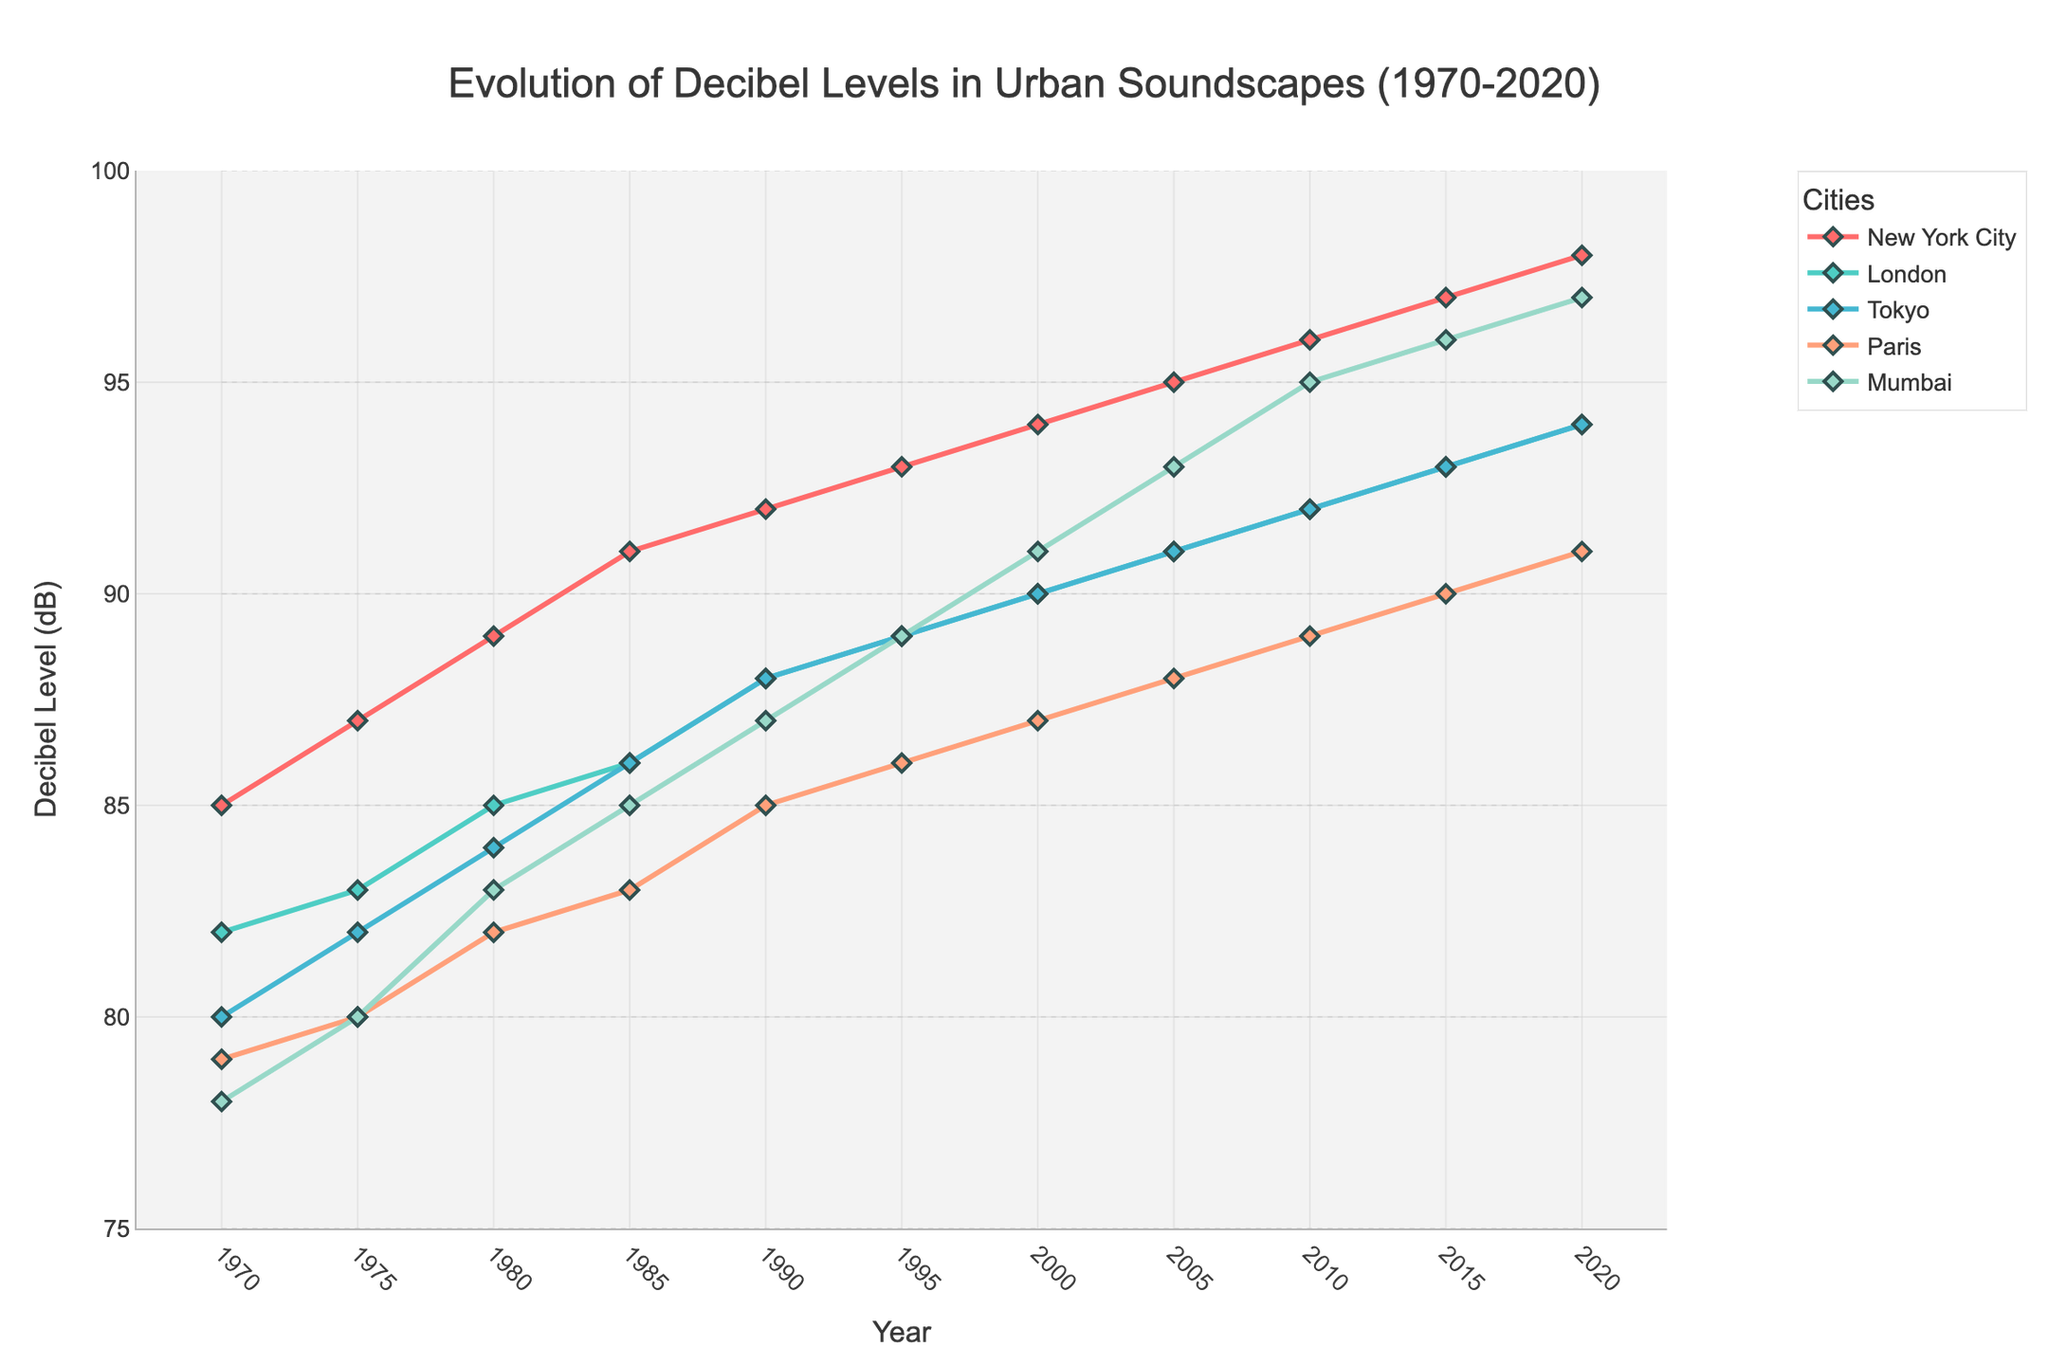What city had the highest decibel level in 2020? By looking at the graph for 2020, find the city with the highest data point on the Y-axis. The city is Mumbai.
Answer: Mumbai Did decibel levels in Tokyo and Paris converge over time? Compare the decibel levels of Tokyo and Paris from 1970 to 2020. They started differently with Tokyo at 80 dB and Paris at 79 dB in 1970, and in 2020 both reached 94 dB, showing convergence.
Answer: Yes Which city had the most constant rate of increase in decibel levels over the 50 years? Evaluate the slope of the lines for each city. New York City, London, Tokyo, and Paris show gradual consistent increases, but Paris has the most constant slope.
Answer: Paris Between which consecutive years did New York City see the largest increase in decibel levels? Check the difference in decibel levels between consecutive years for New York City. The largest increase is between 1980 (89 dB) and 1985 (91 dB), a jump of 2 dB.
Answer: 1980 to 1985 What is the average decibel level for London from 1970 to 2020? Sum the decibel levels for London from 1970 to 2020 (82+83+85+86+88+89+90+91+92+93+94) = 873, then divide by the number of years (11).
Answer: 87.3 Did any cities experience a decrease in decibel levels at any point? Examine each line: no city shows a decrease in decibel levels; all are steadily increasing.
Answer: No How does the rate of increase in decibel levels in Mumbai compare to Tokyo? Visually compare the slopes of Mumbai and Tokyo. Both increase, but Mumbai's slope is steeper, indicating a faster rate of increase.
Answer: Mumbai has a faster increase What was the decibel level difference between New York City and Paris in 2020? Check 2020's data points for both cities: New York City (98 dB) and Paris (91 dB), the difference is 98 - 91.
Answer: 7 dB Which city had the steepest increase in decibel levels from 2005 to 2010? Compare the slopes between 2005 and 2010 for all cities. Mumbai increased from 93 dB to 95 dB, the steepest increase of 2 dB.
Answer: Mumbai 